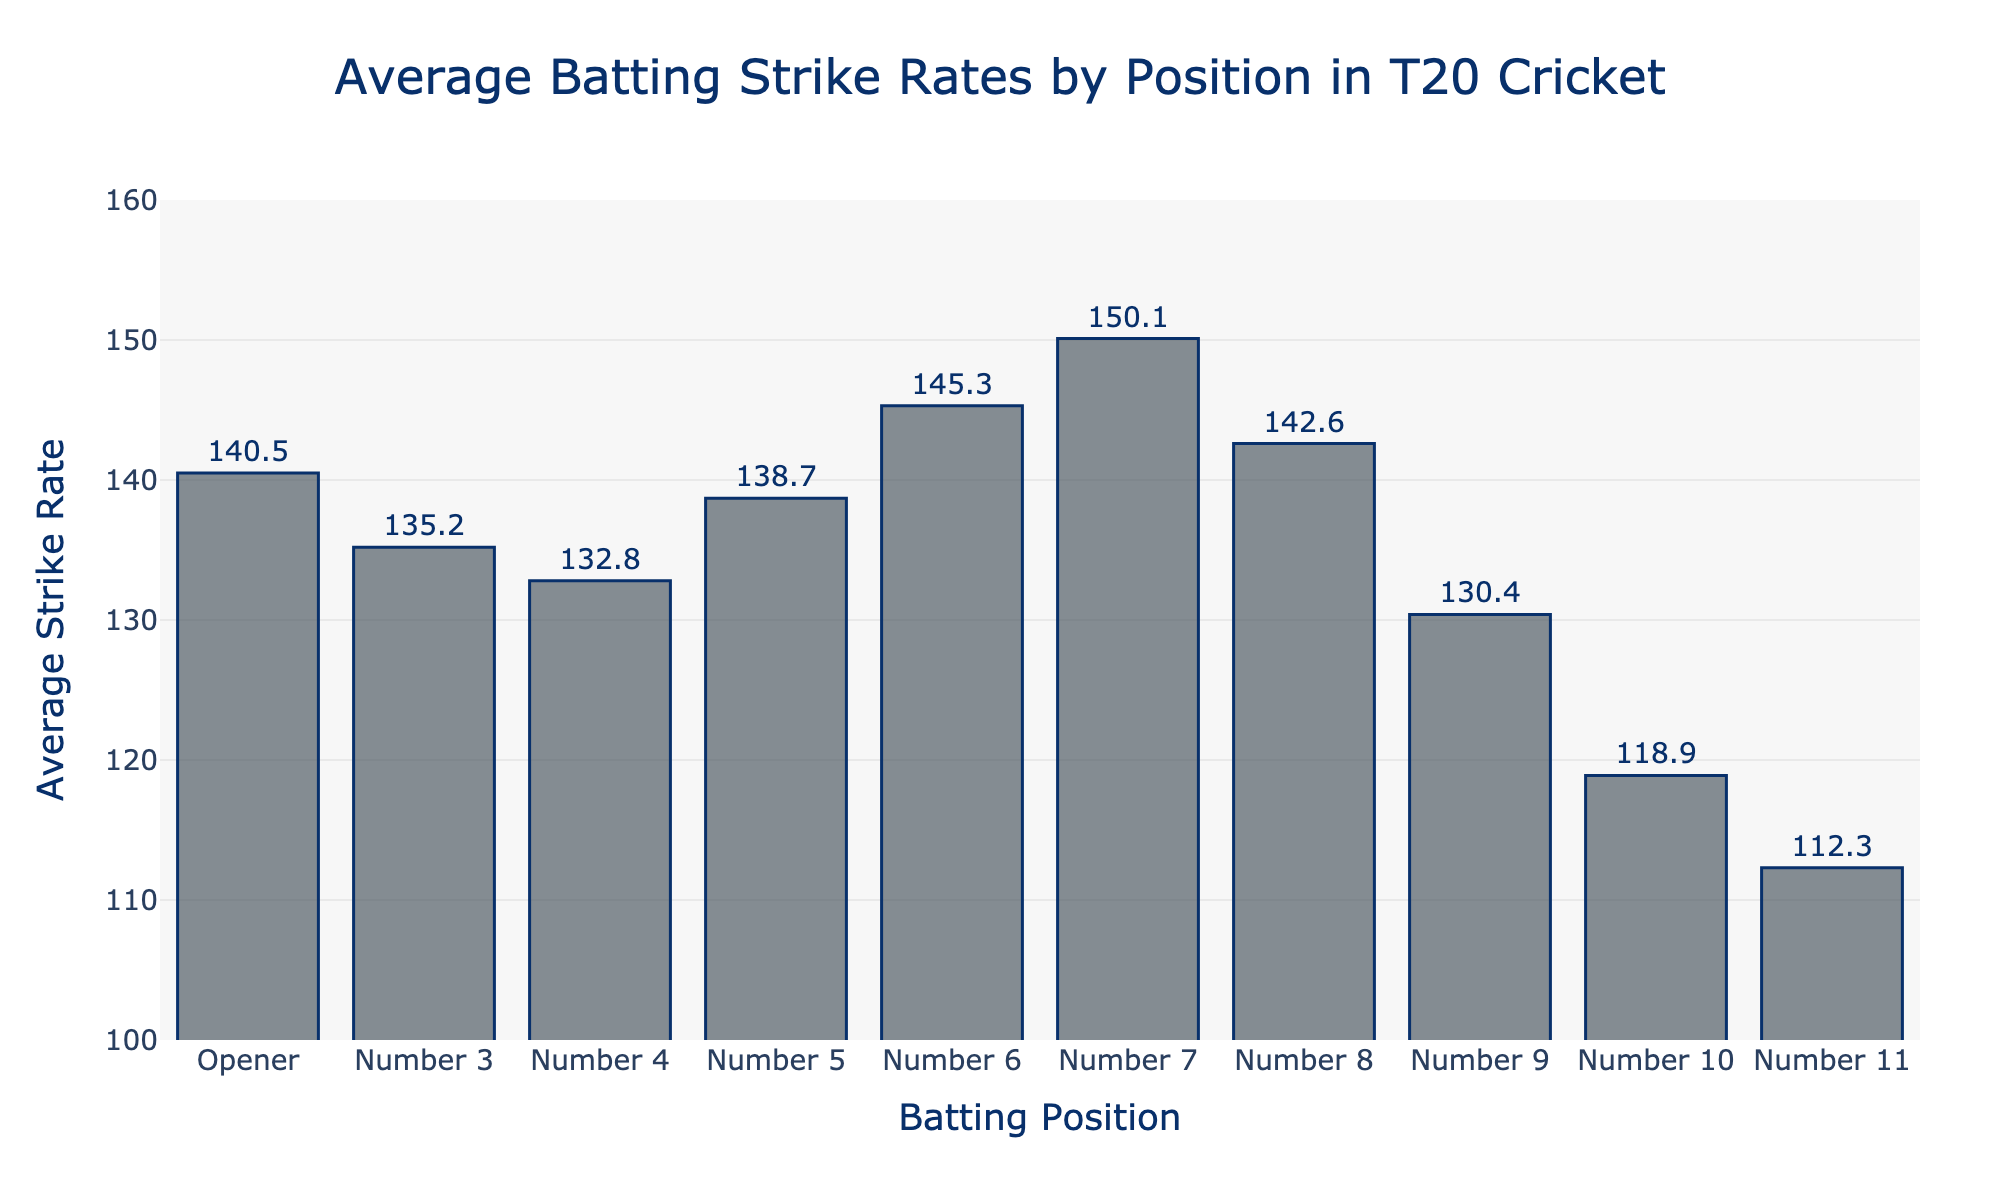What's the average difference in strike rate between positions 7 and 3? To find the average difference, subtract the strike rate of position 3 (135.2) from position 7 (150.1). That gives us 150.1 - 135.2 = 14.9
Answer: 14.9 Which position has the highest average strike rate? From the bar chart, position 7 has the highest average strike rate at 150.1.
Answer: Position 7 What's the range of strike rates from the lowest to the highest position? The range can be calculated by subtracting the lowest strike rate (position 11 at 112.3) from the highest strike rate (position 7 at 150.1). Hence, the range is 150.1 - 112.3 = 37.8
Answer: 37.8 What's the average strike rate of positions 3, 4, and 5 combined? To find this, sum the strike rates of positions 3 (135.2), 4 (132.8), and 5 (138.7), and divide by 3. The calculation is (135.2 + 132.8 + 138.7) / 3 = 406.7 / 3 = 135.57
Answer: 135.57 How much higher is the average strike rate for number 6 compared to the opener? Subtract the strike rate of the opener (140.5) from number 6 (145.3). The difference is 145.3 - 140.5 = 4.8
Answer: 4.8 Which two consecutive positions have the smallest difference in strike rate? By comparing all consecutive positions: 
(140.5 - 135.2) = 5.3, 
(135.2 - 132.8) = 2.4, 
(132.8 - 138.7) = -5.9, 
(138.7 - 145.3) = -6.6, 
(145.3 - 150.1) = -4.8, 
(150.1 - 142.6) = 7.5, 
(142.6 - 130.4) = 12.2, 
(130.4 - 118.9) = 11.5, 
(118.9 - 112.3) = 6.6.
Therefore, positions 3 and 4 have the smallest difference which is 2.4.
Answer: Positions 3 and 4 What's the overall median strike rate for all positions? To find the median, list the strike rates in ascending order: 
112.3, 118.9, 130.4, 132.8, 135.2, 138.7, 140.5, 142.6, 145.3, 150.1.
The median, or the middle value, is the average of the 5th and 6th values: (135.2 + 138.7) / 2 = 273.9 / 2 = 136.95
Answer: 136.95 Is the average strike rate for positions higher than 5 greater than or less than those of positions 5 and lower? To solve this, calculate the averages for each group:
For positions higher than 5 (6, 7, 8, 9, 10, 11): (145.3 + 150.1 + 142.6 + 130.4 + 118.9 + 112.3) / 6 = 800.6 / 6 = 133.43
For positions 5 and lower (Opener, 3, 4, and 5): (140.5 + 135.2 + 132.8 + 138.7) / 4 = 547.2 / 4 = 136.8
Hence, 133.43 < 136.8, so it's less.
Answer: Less 